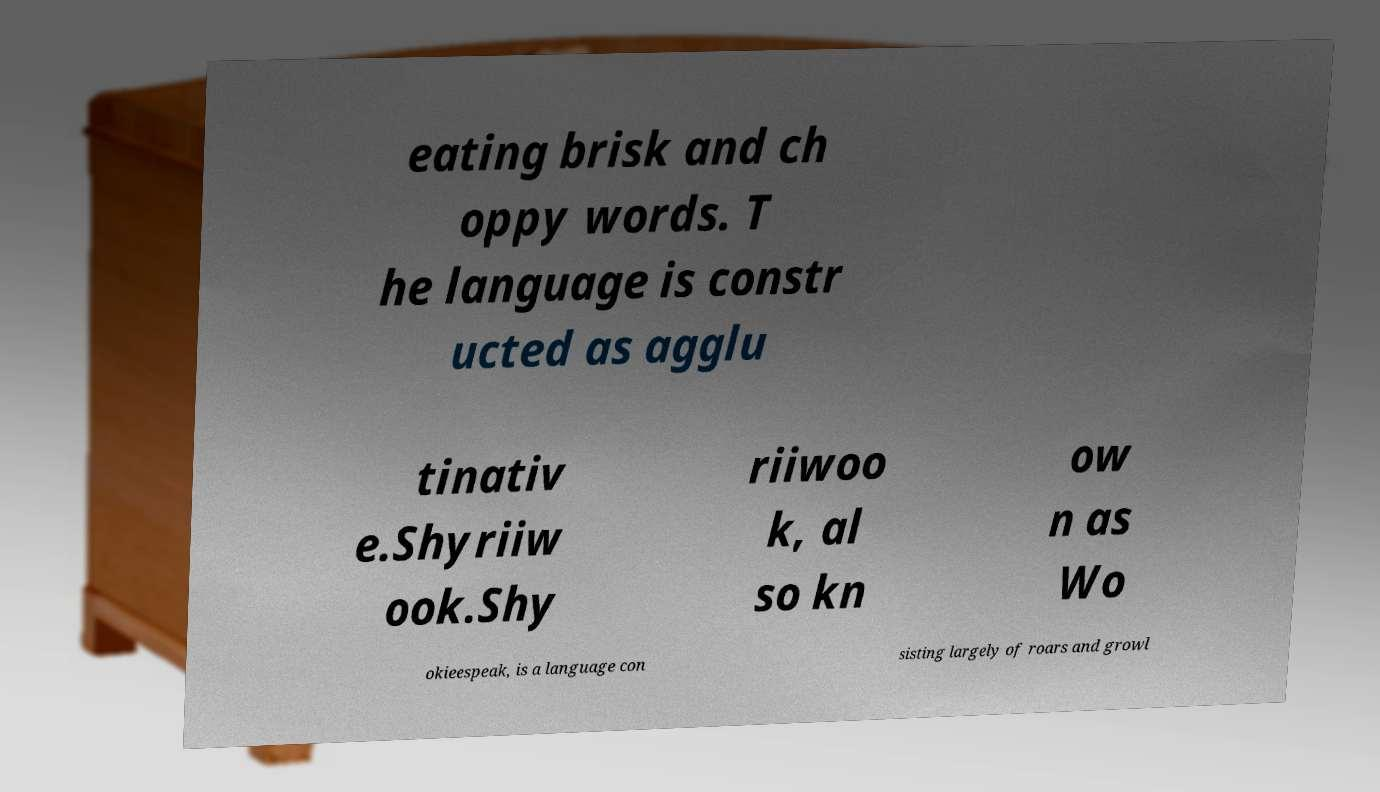Could you assist in decoding the text presented in this image and type it out clearly? eating brisk and ch oppy words. T he language is constr ucted as agglu tinativ e.Shyriiw ook.Shy riiwoo k, al so kn ow n as Wo okieespeak, is a language con sisting largely of roars and growl 